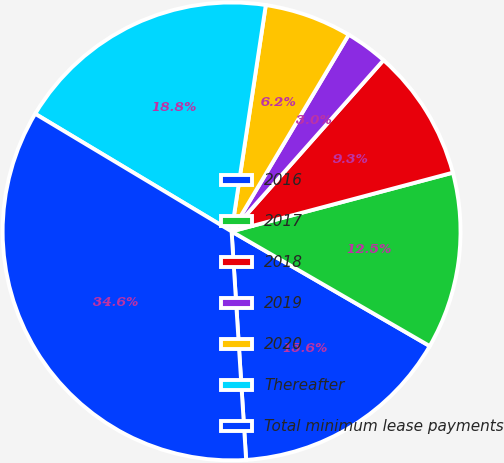<chart> <loc_0><loc_0><loc_500><loc_500><pie_chart><fcel>2016<fcel>2017<fcel>2018<fcel>2019<fcel>2020<fcel>Thereafter<fcel>Total minimum lease payments<nl><fcel>15.64%<fcel>12.48%<fcel>9.32%<fcel>3.0%<fcel>6.16%<fcel>18.8%<fcel>34.6%<nl></chart> 